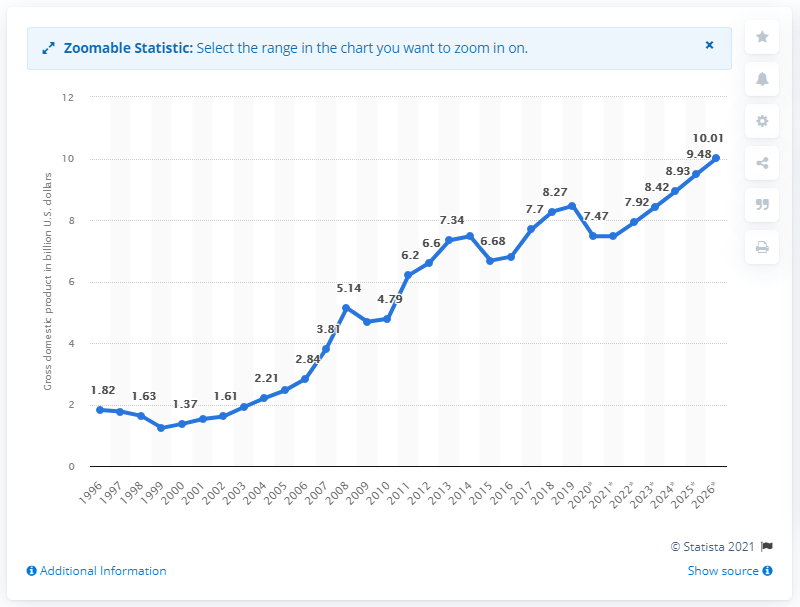Specify some key components in this picture. In 2019, the Gross Domestic Product (GDP) of the Kyrgyz Republic was 8.42. 